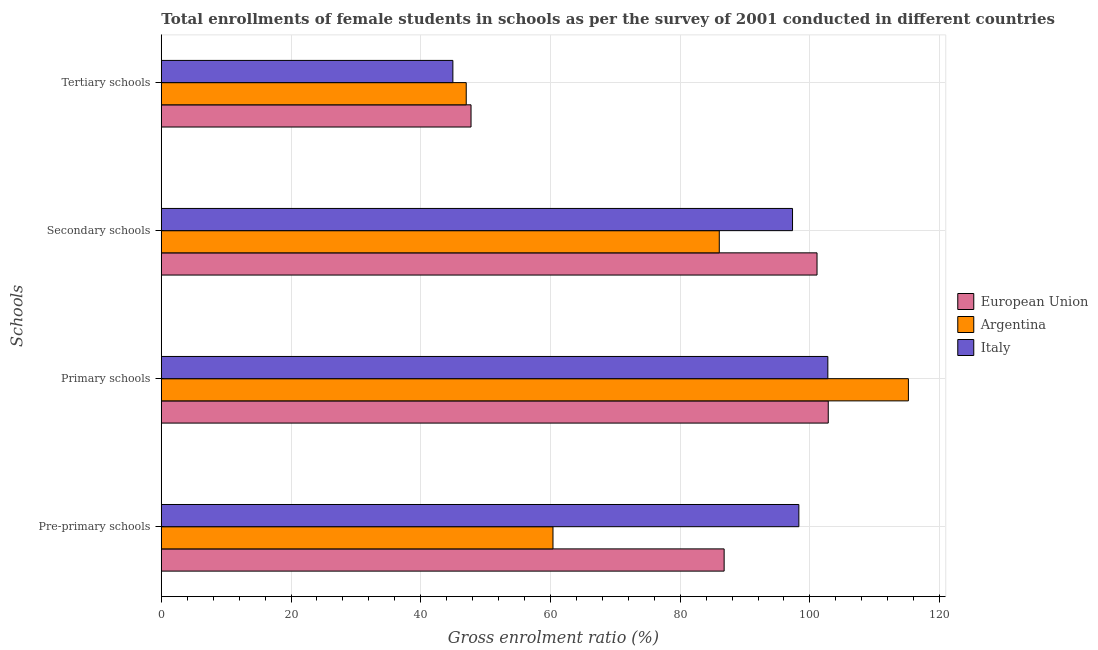Are the number of bars per tick equal to the number of legend labels?
Provide a succinct answer. Yes. How many bars are there on the 3rd tick from the top?
Ensure brevity in your answer.  3. How many bars are there on the 2nd tick from the bottom?
Your answer should be very brief. 3. What is the label of the 2nd group of bars from the top?
Offer a terse response. Secondary schools. What is the gross enrolment ratio(female) in pre-primary schools in Argentina?
Offer a terse response. 60.39. Across all countries, what is the maximum gross enrolment ratio(female) in pre-primary schools?
Your answer should be very brief. 98.29. Across all countries, what is the minimum gross enrolment ratio(female) in secondary schools?
Offer a terse response. 86.02. In which country was the gross enrolment ratio(female) in pre-primary schools maximum?
Your response must be concise. Italy. In which country was the gross enrolment ratio(female) in primary schools minimum?
Keep it short and to the point. Italy. What is the total gross enrolment ratio(female) in primary schools in the graph?
Offer a very short reply. 320.77. What is the difference between the gross enrolment ratio(female) in primary schools in Argentina and that in Italy?
Offer a terse response. 12.42. What is the difference between the gross enrolment ratio(female) in primary schools in European Union and the gross enrolment ratio(female) in pre-primary schools in Argentina?
Make the answer very short. 42.44. What is the average gross enrolment ratio(female) in primary schools per country?
Offer a very short reply. 106.92. What is the difference between the gross enrolment ratio(female) in primary schools and gross enrolment ratio(female) in pre-primary schools in European Union?
Offer a very short reply. 16.05. In how many countries, is the gross enrolment ratio(female) in primary schools greater than 104 %?
Your answer should be compact. 1. What is the ratio of the gross enrolment ratio(female) in pre-primary schools in Italy to that in Argentina?
Offer a very short reply. 1.63. What is the difference between the highest and the second highest gross enrolment ratio(female) in pre-primary schools?
Your answer should be compact. 11.52. What is the difference between the highest and the lowest gross enrolment ratio(female) in secondary schools?
Give a very brief answer. 15.07. In how many countries, is the gross enrolment ratio(female) in secondary schools greater than the average gross enrolment ratio(female) in secondary schools taken over all countries?
Give a very brief answer. 2. Is the sum of the gross enrolment ratio(female) in secondary schools in Argentina and Italy greater than the maximum gross enrolment ratio(female) in tertiary schools across all countries?
Offer a terse response. Yes. Are all the bars in the graph horizontal?
Your answer should be very brief. Yes. How many countries are there in the graph?
Your response must be concise. 3. What is the difference between two consecutive major ticks on the X-axis?
Ensure brevity in your answer.  20. Are the values on the major ticks of X-axis written in scientific E-notation?
Your response must be concise. No. What is the title of the graph?
Provide a succinct answer. Total enrollments of female students in schools as per the survey of 2001 conducted in different countries. Does "Congo (Democratic)" appear as one of the legend labels in the graph?
Make the answer very short. No. What is the label or title of the Y-axis?
Offer a very short reply. Schools. What is the Gross enrolment ratio (%) of European Union in Pre-primary schools?
Your answer should be very brief. 86.77. What is the Gross enrolment ratio (%) in Argentina in Pre-primary schools?
Provide a short and direct response. 60.39. What is the Gross enrolment ratio (%) in Italy in Pre-primary schools?
Give a very brief answer. 98.29. What is the Gross enrolment ratio (%) in European Union in Primary schools?
Your answer should be very brief. 102.83. What is the Gross enrolment ratio (%) of Argentina in Primary schools?
Give a very brief answer. 115.18. What is the Gross enrolment ratio (%) of Italy in Primary schools?
Your answer should be compact. 102.76. What is the Gross enrolment ratio (%) of European Union in Secondary schools?
Ensure brevity in your answer.  101.09. What is the Gross enrolment ratio (%) of Argentina in Secondary schools?
Give a very brief answer. 86.02. What is the Gross enrolment ratio (%) in Italy in Secondary schools?
Offer a terse response. 97.32. What is the Gross enrolment ratio (%) in European Union in Tertiary schools?
Your response must be concise. 47.75. What is the Gross enrolment ratio (%) of Argentina in Tertiary schools?
Give a very brief answer. 47.01. What is the Gross enrolment ratio (%) in Italy in Tertiary schools?
Ensure brevity in your answer.  44.95. Across all Schools, what is the maximum Gross enrolment ratio (%) in European Union?
Offer a very short reply. 102.83. Across all Schools, what is the maximum Gross enrolment ratio (%) in Argentina?
Offer a terse response. 115.18. Across all Schools, what is the maximum Gross enrolment ratio (%) in Italy?
Make the answer very short. 102.76. Across all Schools, what is the minimum Gross enrolment ratio (%) in European Union?
Ensure brevity in your answer.  47.75. Across all Schools, what is the minimum Gross enrolment ratio (%) of Argentina?
Give a very brief answer. 47.01. Across all Schools, what is the minimum Gross enrolment ratio (%) in Italy?
Your answer should be very brief. 44.95. What is the total Gross enrolment ratio (%) of European Union in the graph?
Provide a short and direct response. 338.45. What is the total Gross enrolment ratio (%) in Argentina in the graph?
Your answer should be very brief. 308.61. What is the total Gross enrolment ratio (%) in Italy in the graph?
Give a very brief answer. 343.33. What is the difference between the Gross enrolment ratio (%) in European Union in Pre-primary schools and that in Primary schools?
Your answer should be compact. -16.05. What is the difference between the Gross enrolment ratio (%) in Argentina in Pre-primary schools and that in Primary schools?
Your answer should be very brief. -54.8. What is the difference between the Gross enrolment ratio (%) in Italy in Pre-primary schools and that in Primary schools?
Offer a very short reply. -4.47. What is the difference between the Gross enrolment ratio (%) of European Union in Pre-primary schools and that in Secondary schools?
Give a very brief answer. -14.32. What is the difference between the Gross enrolment ratio (%) in Argentina in Pre-primary schools and that in Secondary schools?
Give a very brief answer. -25.64. What is the difference between the Gross enrolment ratio (%) of Italy in Pre-primary schools and that in Secondary schools?
Offer a very short reply. 0.98. What is the difference between the Gross enrolment ratio (%) in European Union in Pre-primary schools and that in Tertiary schools?
Ensure brevity in your answer.  39.02. What is the difference between the Gross enrolment ratio (%) in Argentina in Pre-primary schools and that in Tertiary schools?
Provide a short and direct response. 13.37. What is the difference between the Gross enrolment ratio (%) in Italy in Pre-primary schools and that in Tertiary schools?
Your answer should be very brief. 53.34. What is the difference between the Gross enrolment ratio (%) of European Union in Primary schools and that in Secondary schools?
Keep it short and to the point. 1.73. What is the difference between the Gross enrolment ratio (%) in Argentina in Primary schools and that in Secondary schools?
Ensure brevity in your answer.  29.16. What is the difference between the Gross enrolment ratio (%) in Italy in Primary schools and that in Secondary schools?
Your answer should be very brief. 5.45. What is the difference between the Gross enrolment ratio (%) of European Union in Primary schools and that in Tertiary schools?
Your answer should be very brief. 55.07. What is the difference between the Gross enrolment ratio (%) in Argentina in Primary schools and that in Tertiary schools?
Offer a terse response. 68.17. What is the difference between the Gross enrolment ratio (%) of Italy in Primary schools and that in Tertiary schools?
Make the answer very short. 57.81. What is the difference between the Gross enrolment ratio (%) in European Union in Secondary schools and that in Tertiary schools?
Provide a succinct answer. 53.34. What is the difference between the Gross enrolment ratio (%) of Argentina in Secondary schools and that in Tertiary schools?
Keep it short and to the point. 39.01. What is the difference between the Gross enrolment ratio (%) in Italy in Secondary schools and that in Tertiary schools?
Keep it short and to the point. 52.37. What is the difference between the Gross enrolment ratio (%) of European Union in Pre-primary schools and the Gross enrolment ratio (%) of Argentina in Primary schools?
Keep it short and to the point. -28.41. What is the difference between the Gross enrolment ratio (%) of European Union in Pre-primary schools and the Gross enrolment ratio (%) of Italy in Primary schools?
Offer a terse response. -15.99. What is the difference between the Gross enrolment ratio (%) in Argentina in Pre-primary schools and the Gross enrolment ratio (%) in Italy in Primary schools?
Ensure brevity in your answer.  -42.38. What is the difference between the Gross enrolment ratio (%) in European Union in Pre-primary schools and the Gross enrolment ratio (%) in Argentina in Secondary schools?
Give a very brief answer. 0.75. What is the difference between the Gross enrolment ratio (%) in European Union in Pre-primary schools and the Gross enrolment ratio (%) in Italy in Secondary schools?
Your answer should be very brief. -10.54. What is the difference between the Gross enrolment ratio (%) of Argentina in Pre-primary schools and the Gross enrolment ratio (%) of Italy in Secondary schools?
Your answer should be very brief. -36.93. What is the difference between the Gross enrolment ratio (%) of European Union in Pre-primary schools and the Gross enrolment ratio (%) of Argentina in Tertiary schools?
Your answer should be compact. 39.76. What is the difference between the Gross enrolment ratio (%) of European Union in Pre-primary schools and the Gross enrolment ratio (%) of Italy in Tertiary schools?
Your answer should be very brief. 41.82. What is the difference between the Gross enrolment ratio (%) in Argentina in Pre-primary schools and the Gross enrolment ratio (%) in Italy in Tertiary schools?
Ensure brevity in your answer.  15.44. What is the difference between the Gross enrolment ratio (%) in European Union in Primary schools and the Gross enrolment ratio (%) in Argentina in Secondary schools?
Offer a very short reply. 16.8. What is the difference between the Gross enrolment ratio (%) in European Union in Primary schools and the Gross enrolment ratio (%) in Italy in Secondary schools?
Provide a short and direct response. 5.51. What is the difference between the Gross enrolment ratio (%) of Argentina in Primary schools and the Gross enrolment ratio (%) of Italy in Secondary schools?
Your answer should be very brief. 17.86. What is the difference between the Gross enrolment ratio (%) of European Union in Primary schools and the Gross enrolment ratio (%) of Argentina in Tertiary schools?
Ensure brevity in your answer.  55.81. What is the difference between the Gross enrolment ratio (%) in European Union in Primary schools and the Gross enrolment ratio (%) in Italy in Tertiary schools?
Make the answer very short. 57.88. What is the difference between the Gross enrolment ratio (%) of Argentina in Primary schools and the Gross enrolment ratio (%) of Italy in Tertiary schools?
Ensure brevity in your answer.  70.23. What is the difference between the Gross enrolment ratio (%) in European Union in Secondary schools and the Gross enrolment ratio (%) in Argentina in Tertiary schools?
Your response must be concise. 54.08. What is the difference between the Gross enrolment ratio (%) in European Union in Secondary schools and the Gross enrolment ratio (%) in Italy in Tertiary schools?
Make the answer very short. 56.14. What is the difference between the Gross enrolment ratio (%) in Argentina in Secondary schools and the Gross enrolment ratio (%) in Italy in Tertiary schools?
Offer a very short reply. 41.07. What is the average Gross enrolment ratio (%) in European Union per Schools?
Ensure brevity in your answer.  84.61. What is the average Gross enrolment ratio (%) of Argentina per Schools?
Your response must be concise. 77.15. What is the average Gross enrolment ratio (%) in Italy per Schools?
Give a very brief answer. 85.83. What is the difference between the Gross enrolment ratio (%) in European Union and Gross enrolment ratio (%) in Argentina in Pre-primary schools?
Provide a succinct answer. 26.39. What is the difference between the Gross enrolment ratio (%) of European Union and Gross enrolment ratio (%) of Italy in Pre-primary schools?
Make the answer very short. -11.52. What is the difference between the Gross enrolment ratio (%) in Argentina and Gross enrolment ratio (%) in Italy in Pre-primary schools?
Give a very brief answer. -37.91. What is the difference between the Gross enrolment ratio (%) in European Union and Gross enrolment ratio (%) in Argentina in Primary schools?
Offer a very short reply. -12.36. What is the difference between the Gross enrolment ratio (%) of European Union and Gross enrolment ratio (%) of Italy in Primary schools?
Give a very brief answer. 0.06. What is the difference between the Gross enrolment ratio (%) in Argentina and Gross enrolment ratio (%) in Italy in Primary schools?
Keep it short and to the point. 12.42. What is the difference between the Gross enrolment ratio (%) in European Union and Gross enrolment ratio (%) in Argentina in Secondary schools?
Ensure brevity in your answer.  15.07. What is the difference between the Gross enrolment ratio (%) in European Union and Gross enrolment ratio (%) in Italy in Secondary schools?
Offer a very short reply. 3.78. What is the difference between the Gross enrolment ratio (%) of Argentina and Gross enrolment ratio (%) of Italy in Secondary schools?
Keep it short and to the point. -11.29. What is the difference between the Gross enrolment ratio (%) in European Union and Gross enrolment ratio (%) in Argentina in Tertiary schools?
Offer a very short reply. 0.74. What is the difference between the Gross enrolment ratio (%) in European Union and Gross enrolment ratio (%) in Italy in Tertiary schools?
Your answer should be compact. 2.8. What is the difference between the Gross enrolment ratio (%) of Argentina and Gross enrolment ratio (%) of Italy in Tertiary schools?
Provide a succinct answer. 2.06. What is the ratio of the Gross enrolment ratio (%) in European Union in Pre-primary schools to that in Primary schools?
Make the answer very short. 0.84. What is the ratio of the Gross enrolment ratio (%) in Argentina in Pre-primary schools to that in Primary schools?
Provide a succinct answer. 0.52. What is the ratio of the Gross enrolment ratio (%) of Italy in Pre-primary schools to that in Primary schools?
Your answer should be very brief. 0.96. What is the ratio of the Gross enrolment ratio (%) of European Union in Pre-primary schools to that in Secondary schools?
Keep it short and to the point. 0.86. What is the ratio of the Gross enrolment ratio (%) in Argentina in Pre-primary schools to that in Secondary schools?
Provide a short and direct response. 0.7. What is the ratio of the Gross enrolment ratio (%) in Italy in Pre-primary schools to that in Secondary schools?
Provide a short and direct response. 1.01. What is the ratio of the Gross enrolment ratio (%) of European Union in Pre-primary schools to that in Tertiary schools?
Provide a succinct answer. 1.82. What is the ratio of the Gross enrolment ratio (%) in Argentina in Pre-primary schools to that in Tertiary schools?
Keep it short and to the point. 1.28. What is the ratio of the Gross enrolment ratio (%) in Italy in Pre-primary schools to that in Tertiary schools?
Keep it short and to the point. 2.19. What is the ratio of the Gross enrolment ratio (%) in European Union in Primary schools to that in Secondary schools?
Make the answer very short. 1.02. What is the ratio of the Gross enrolment ratio (%) in Argentina in Primary schools to that in Secondary schools?
Your response must be concise. 1.34. What is the ratio of the Gross enrolment ratio (%) of Italy in Primary schools to that in Secondary schools?
Your response must be concise. 1.06. What is the ratio of the Gross enrolment ratio (%) of European Union in Primary schools to that in Tertiary schools?
Offer a terse response. 2.15. What is the ratio of the Gross enrolment ratio (%) of Argentina in Primary schools to that in Tertiary schools?
Provide a short and direct response. 2.45. What is the ratio of the Gross enrolment ratio (%) of Italy in Primary schools to that in Tertiary schools?
Provide a short and direct response. 2.29. What is the ratio of the Gross enrolment ratio (%) of European Union in Secondary schools to that in Tertiary schools?
Provide a succinct answer. 2.12. What is the ratio of the Gross enrolment ratio (%) in Argentina in Secondary schools to that in Tertiary schools?
Keep it short and to the point. 1.83. What is the ratio of the Gross enrolment ratio (%) in Italy in Secondary schools to that in Tertiary schools?
Your response must be concise. 2.17. What is the difference between the highest and the second highest Gross enrolment ratio (%) in European Union?
Give a very brief answer. 1.73. What is the difference between the highest and the second highest Gross enrolment ratio (%) of Argentina?
Provide a succinct answer. 29.16. What is the difference between the highest and the second highest Gross enrolment ratio (%) in Italy?
Keep it short and to the point. 4.47. What is the difference between the highest and the lowest Gross enrolment ratio (%) in European Union?
Provide a succinct answer. 55.07. What is the difference between the highest and the lowest Gross enrolment ratio (%) of Argentina?
Keep it short and to the point. 68.17. What is the difference between the highest and the lowest Gross enrolment ratio (%) in Italy?
Keep it short and to the point. 57.81. 